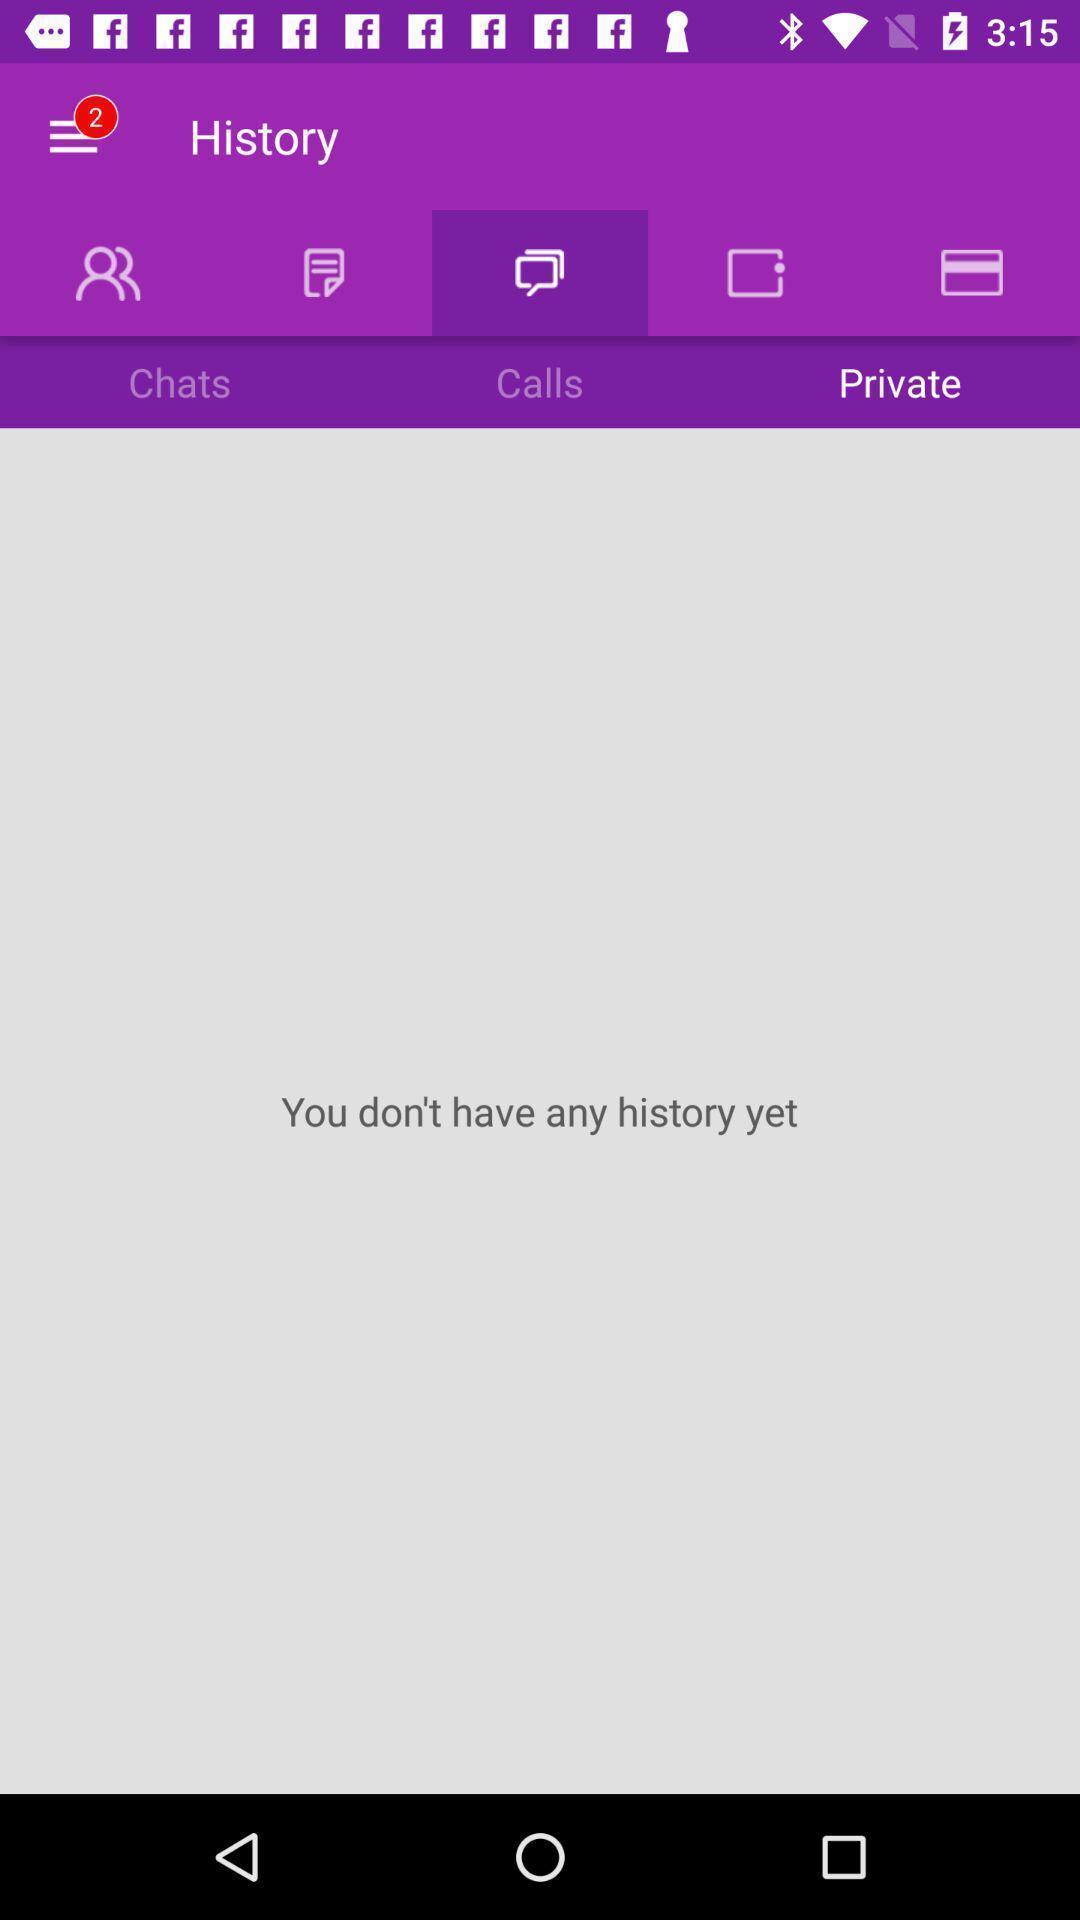Tell me about the visual elements in this screen capture. Screen shows history page. 